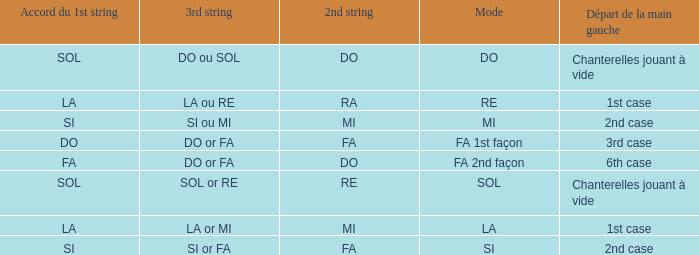For the 2nd string of Ra what is the Depart de la main gauche? 1st case. 